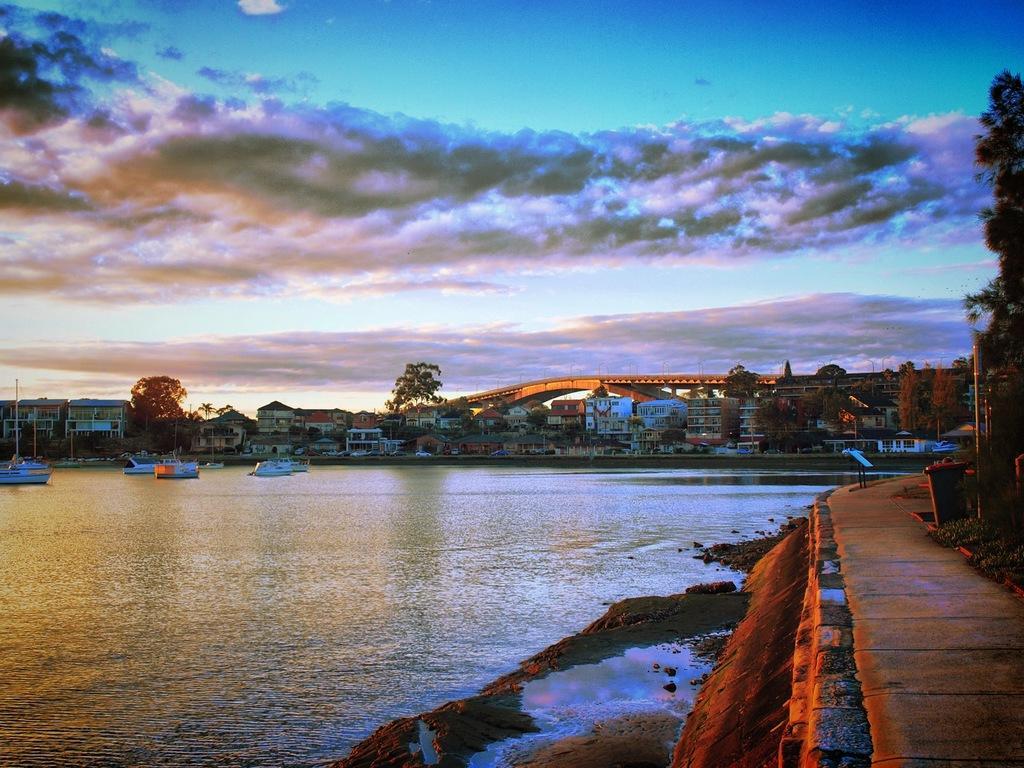Describe this image in one or two sentences. In this image we can see boats on the surface of water. On the right side of the image, we can see a pathway, dustbin and plants. In the background, we can see buildings, trees, bridge and poles. At the top of the image, we can see the sky with clouds. 